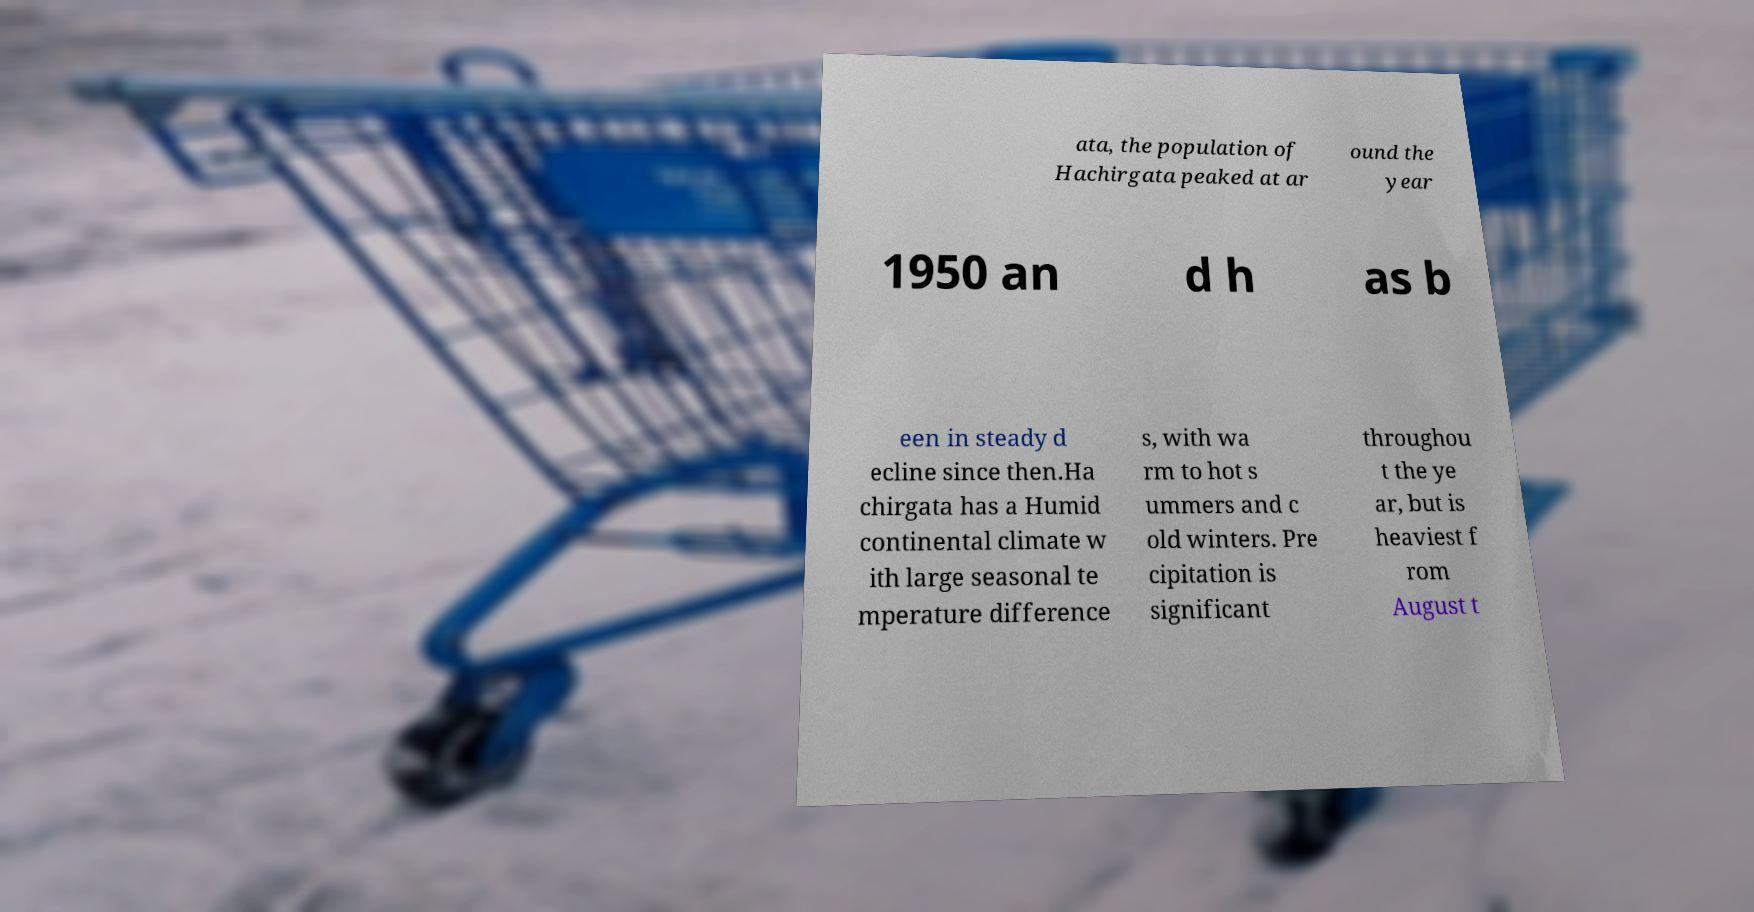Could you extract and type out the text from this image? ata, the population of Hachirgata peaked at ar ound the year 1950 an d h as b een in steady d ecline since then.Ha chirgata has a Humid continental climate w ith large seasonal te mperature difference s, with wa rm to hot s ummers and c old winters. Pre cipitation is significant throughou t the ye ar, but is heaviest f rom August t 